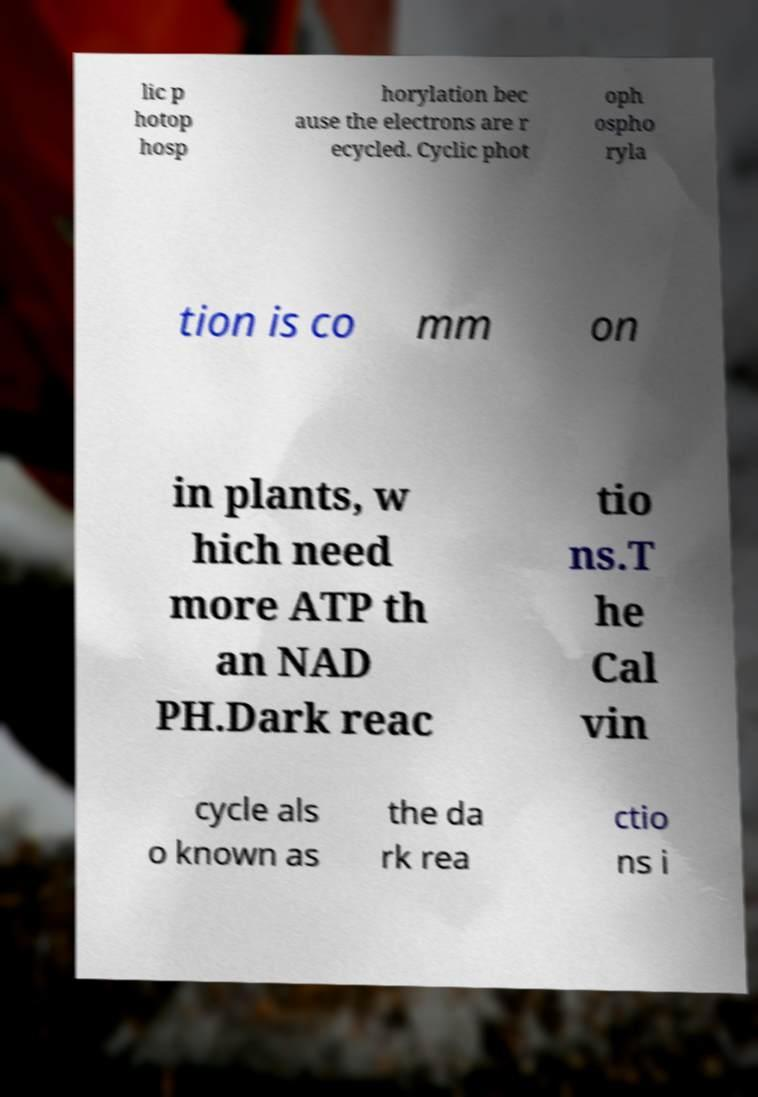I need the written content from this picture converted into text. Can you do that? lic p hotop hosp horylation bec ause the electrons are r ecycled. Cyclic phot oph ospho ryla tion is co mm on in plants, w hich need more ATP th an NAD PH.Dark reac tio ns.T he Cal vin cycle als o known as the da rk rea ctio ns i 